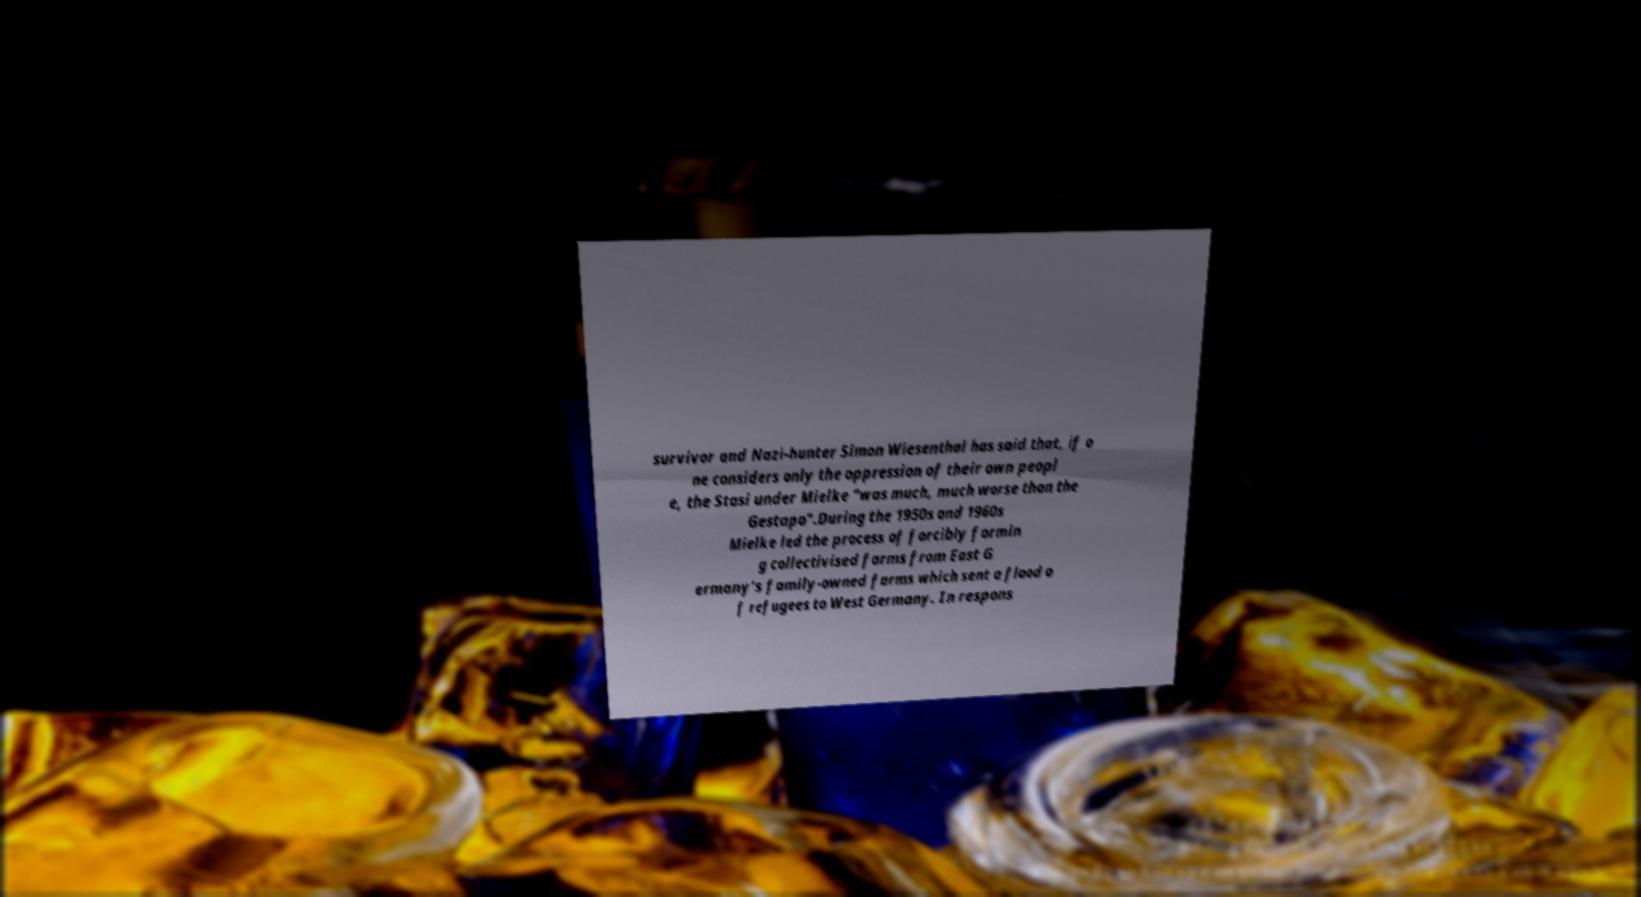Please identify and transcribe the text found in this image. survivor and Nazi-hunter Simon Wiesenthal has said that, if o ne considers only the oppression of their own peopl e, the Stasi under Mielke "was much, much worse than the Gestapo".During the 1950s and 1960s Mielke led the process of forcibly formin g collectivised farms from East G ermany's family-owned farms which sent a flood o f refugees to West Germany. In respons 